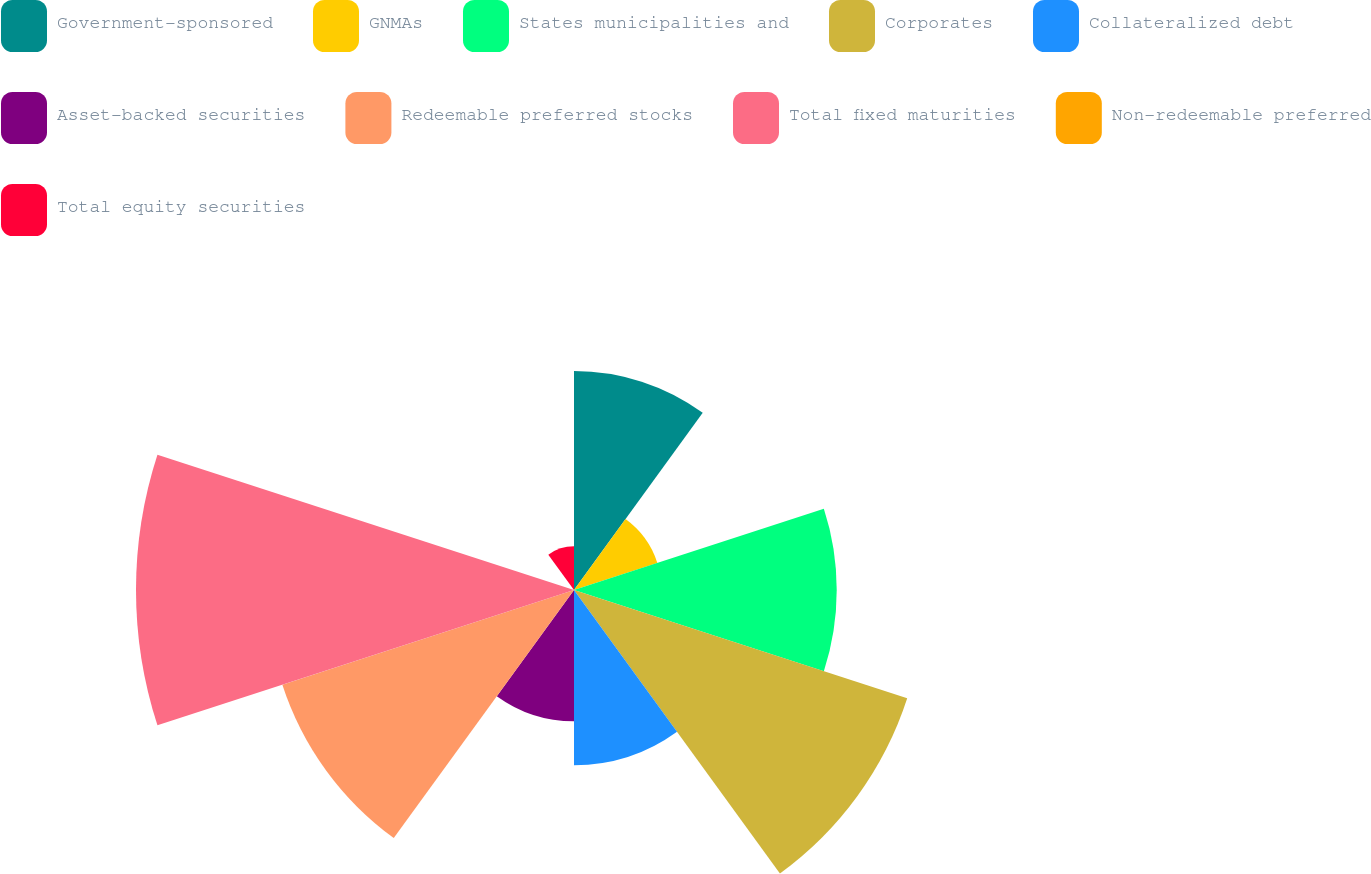Convert chart to OTSL. <chart><loc_0><loc_0><loc_500><loc_500><pie_chart><fcel>Government-sponsored<fcel>GNMAs<fcel>States municipalities and<fcel>Corporates<fcel>Collateralized debt<fcel>Asset-backed securities<fcel>Redeemable preferred stocks<fcel>Total fixed maturities<fcel>Non-redeemable preferred<fcel>Total equity securities<nl><fcel>10.87%<fcel>4.35%<fcel>13.04%<fcel>17.39%<fcel>8.7%<fcel>6.52%<fcel>15.22%<fcel>21.74%<fcel>0.0%<fcel>2.17%<nl></chart> 